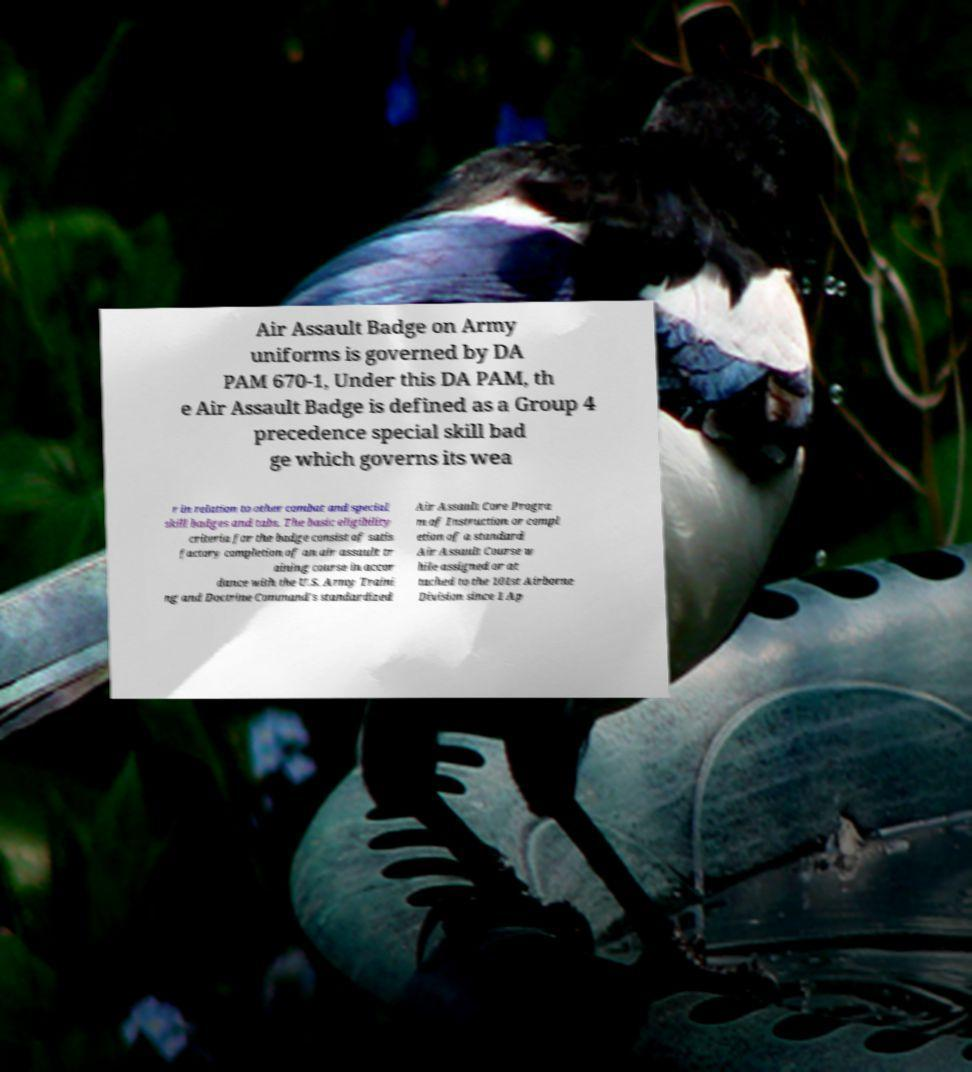Please read and relay the text visible in this image. What does it say? Air Assault Badge on Army uniforms is governed by DA PAM 670-1, Under this DA PAM, th e Air Assault Badge is defined as a Group 4 precedence special skill bad ge which governs its wea r in relation to other combat and special skill badges and tabs. The basic eligibility criteria for the badge consist of satis factory completion of an air assault tr aining course in accor dance with the U.S. Army Traini ng and Doctrine Command's standardized Air Assault Core Progra m of Instruction or compl etion of a standard Air Assault Course w hile assigned or at tached to the 101st Airborne Division since 1 Ap 